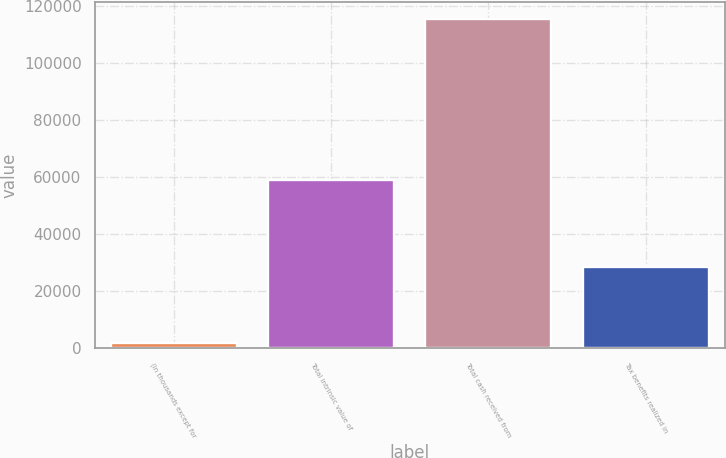Convert chart. <chart><loc_0><loc_0><loc_500><loc_500><bar_chart><fcel>(In thousands except for<fcel>Total intrinsic value of<fcel>Total cash received from<fcel>Tax benefits realized in<nl><fcel>2008<fcel>58960<fcel>115556<fcel>28569<nl></chart> 